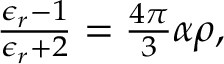Convert formula to latex. <formula><loc_0><loc_0><loc_500><loc_500>\begin{array} { r } { \frac { \epsilon _ { r } - 1 } { \epsilon _ { r } + 2 } = \frac { 4 \pi } { 3 } \alpha \rho , } \end{array}</formula> 